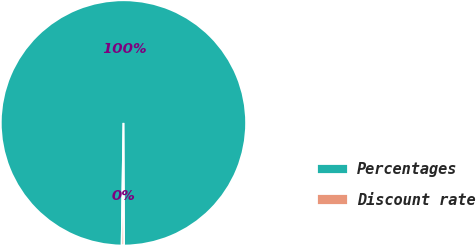Convert chart to OTSL. <chart><loc_0><loc_0><loc_500><loc_500><pie_chart><fcel>Percentages<fcel>Discount rate<nl><fcel>99.69%<fcel>0.31%<nl></chart> 